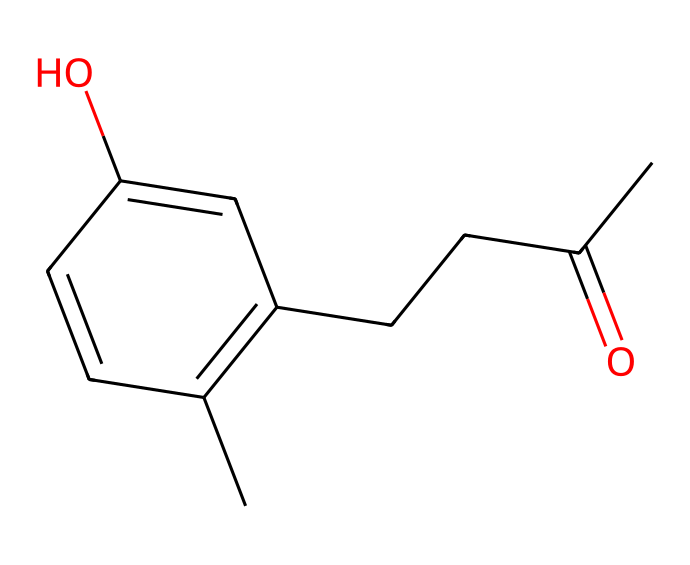how many carbon atoms are in raspberry ketone? The SMILES notation indicates the presence of carbon ('C') atoms. Counting the number of carbon atoms in the structure reveals there are 10 carbon atoms.
Answer: 10 how many double bonds are present in this compound? Analyzing the SMILES structure, a double bond occurs in the carbonyl group (C=O) and in the ring structure (C=C) as we go through the molecule. There are 2 double bonds in total.
Answer: 2 what type of functional group is present in raspberry ketone? In the given structure, the presence of the carbonyl group (C=O) indicates that this compound belongs to the ketone family.
Answer: ketone is raspberry ketone aromatic? Observing the presence of a six-membered carbon ring with alternating double bonds indicates that the compound has an aromatic nature.
Answer: yes how many hydroxyl (–OH) groups are present in raspberry ketone? The SMILES representation shows an –OH group attached to the aromatic ring of the compound. Therefore, there is one hydroxyl group present.
Answer: 1 what is the molecular formula for raspberry ketone? By identifying the number of each type of atom in the compound through the SMILES notation (10 carbons, 10 hydrogens, and 1 oxygen), the molecular formula can be constructed as C10H10O.
Answer: C10H10O 